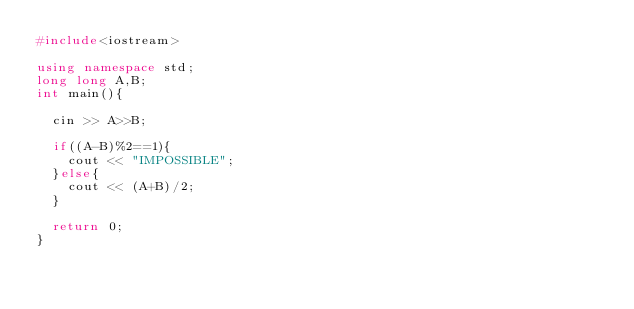Convert code to text. <code><loc_0><loc_0><loc_500><loc_500><_C++_>#include<iostream>

using namespace std;
long long A,B;
int main(){

  cin >> A>>B;

  if((A-B)%2==1){
    cout << "IMPOSSIBLE";
  }else{
    cout << (A+B)/2;
  }

  return 0;
}
</code> 